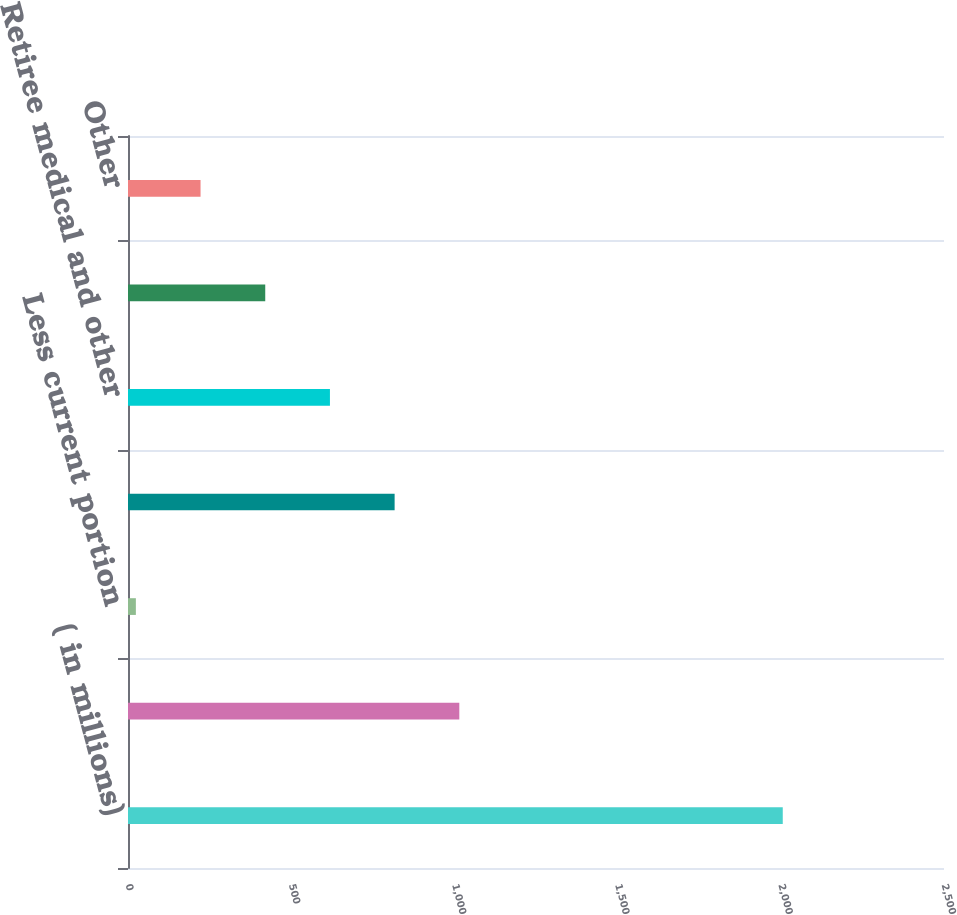Convert chart to OTSL. <chart><loc_0><loc_0><loc_500><loc_500><bar_chart><fcel>( in millions)<fcel>Total defined benefit pension<fcel>Less current portion<fcel>Long-term defined benefit<fcel>Retiree medical and other<fcel>Deferred compensation<fcel>Other<nl><fcel>2006<fcel>1015.05<fcel>24.1<fcel>816.86<fcel>618.67<fcel>420.48<fcel>222.29<nl></chart> 